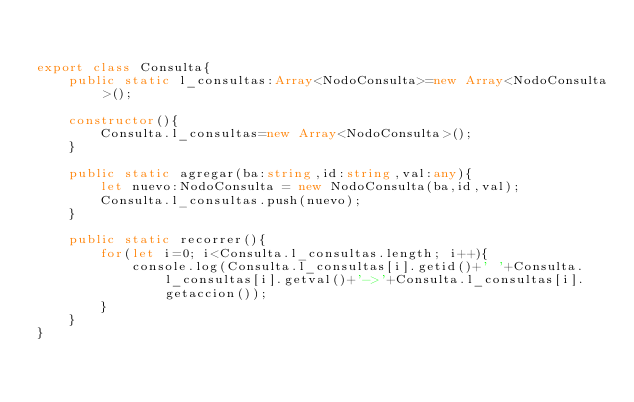<code> <loc_0><loc_0><loc_500><loc_500><_TypeScript_>

export class Consulta{
    public static l_consultas:Array<NodoConsulta>=new Array<NodoConsulta>();

    constructor(){
        Consulta.l_consultas=new Array<NodoConsulta>();
    }

    public static agregar(ba:string,id:string,val:any){
        let nuevo:NodoConsulta = new NodoConsulta(ba,id,val);
        Consulta.l_consultas.push(nuevo);
    }

    public static recorrer(){
        for(let i=0; i<Consulta.l_consultas.length; i++){
            console.log(Consulta.l_consultas[i].getid()+' '+Consulta.l_consultas[i].getval()+'->'+Consulta.l_consultas[i].getaccion());
        }
    }
}</code> 